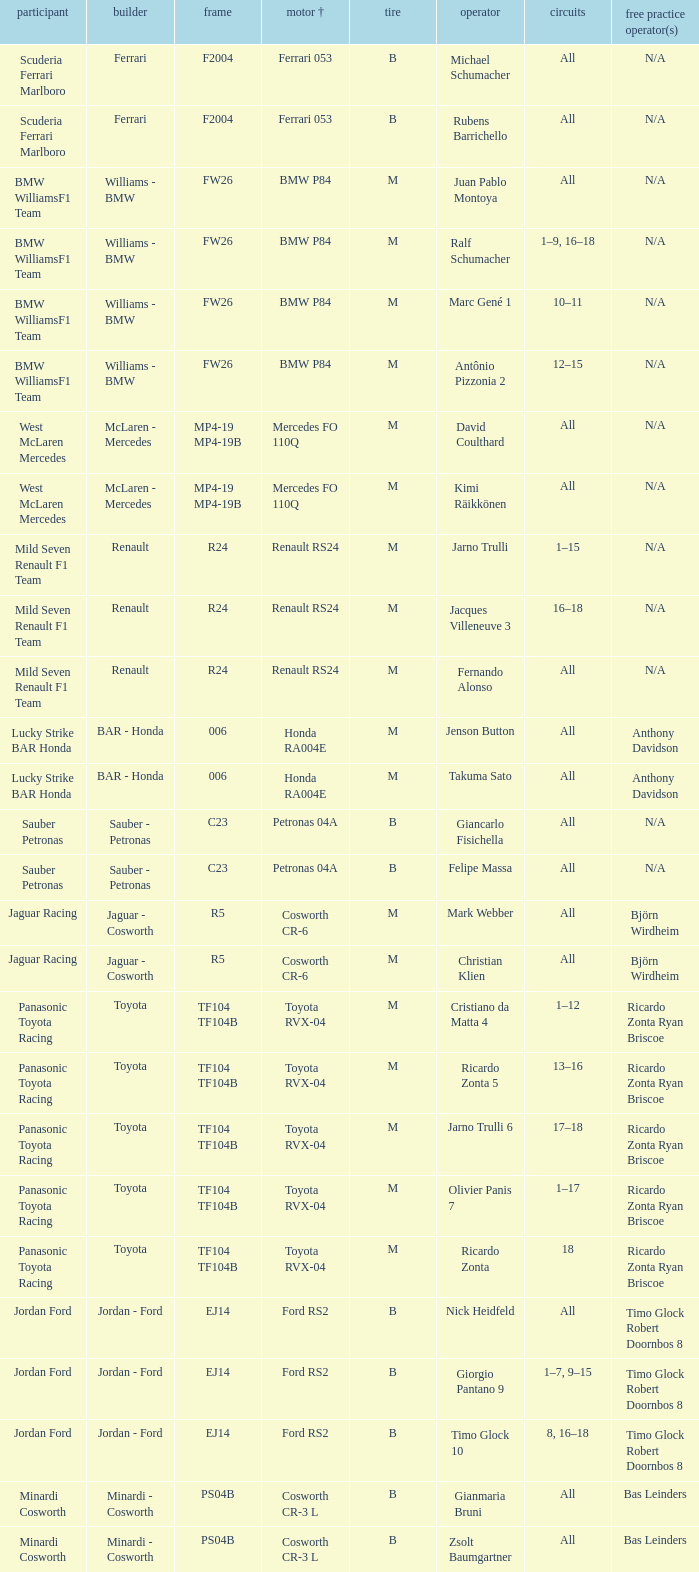What kind of free practice is there with a Ford RS2 engine +? Timo Glock Robert Doornbos 8, Timo Glock Robert Doornbos 8, Timo Glock Robert Doornbos 8. 